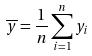<formula> <loc_0><loc_0><loc_500><loc_500>\overline { y } = \frac { 1 } { n } \sum _ { i = 1 } ^ { n } y _ { i }</formula> 